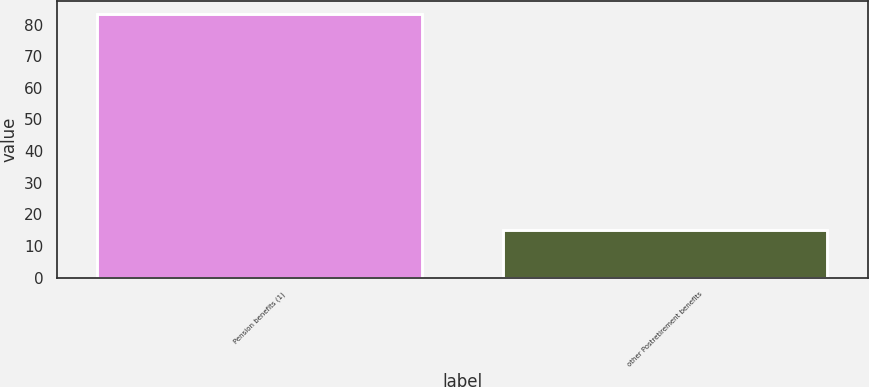Convert chart to OTSL. <chart><loc_0><loc_0><loc_500><loc_500><bar_chart><fcel>Pension benefits (1)<fcel>other Postretirement benefits<nl><fcel>83.4<fcel>15.2<nl></chart> 